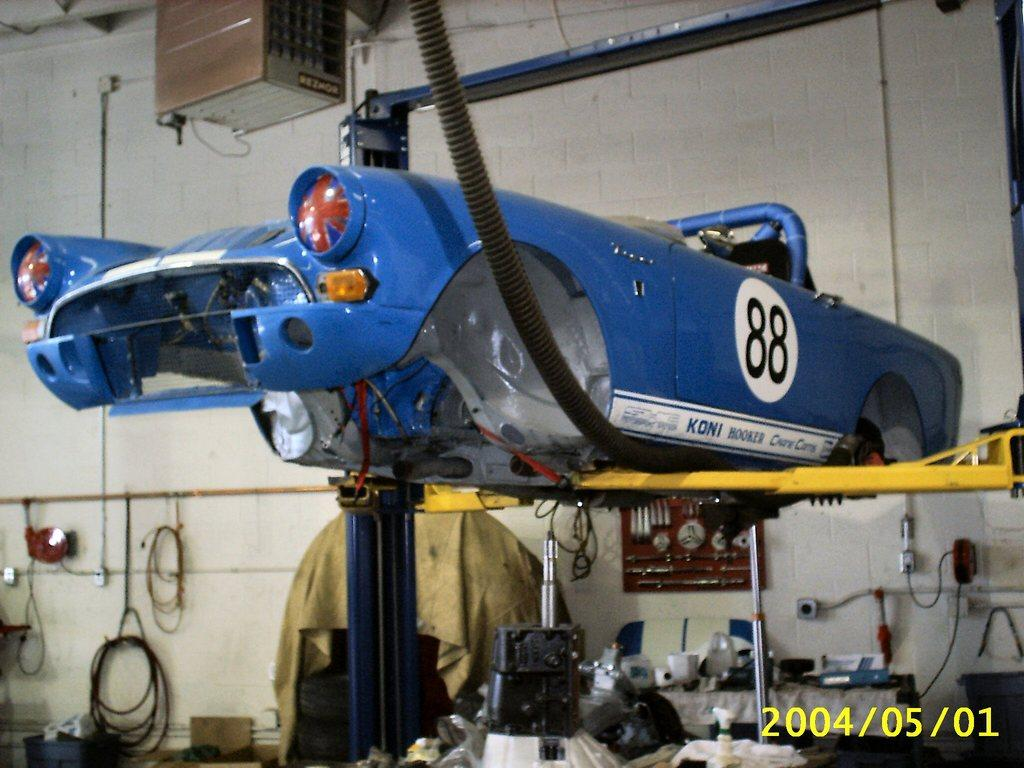What color is the car body in the image? The car body in the image is blue. Where is the car located in the image? The image appears to be set in a mechanic shed. What can be found in the mechanic shed besides the car? There are many tools visible in the image. What is visible in the background of the image? There is a wall in the background of the image. Is the moon visible in the image? No, the moon is not visible in the image. The image is set in a mechanic shed, and the background shows a wall, not the sky. 